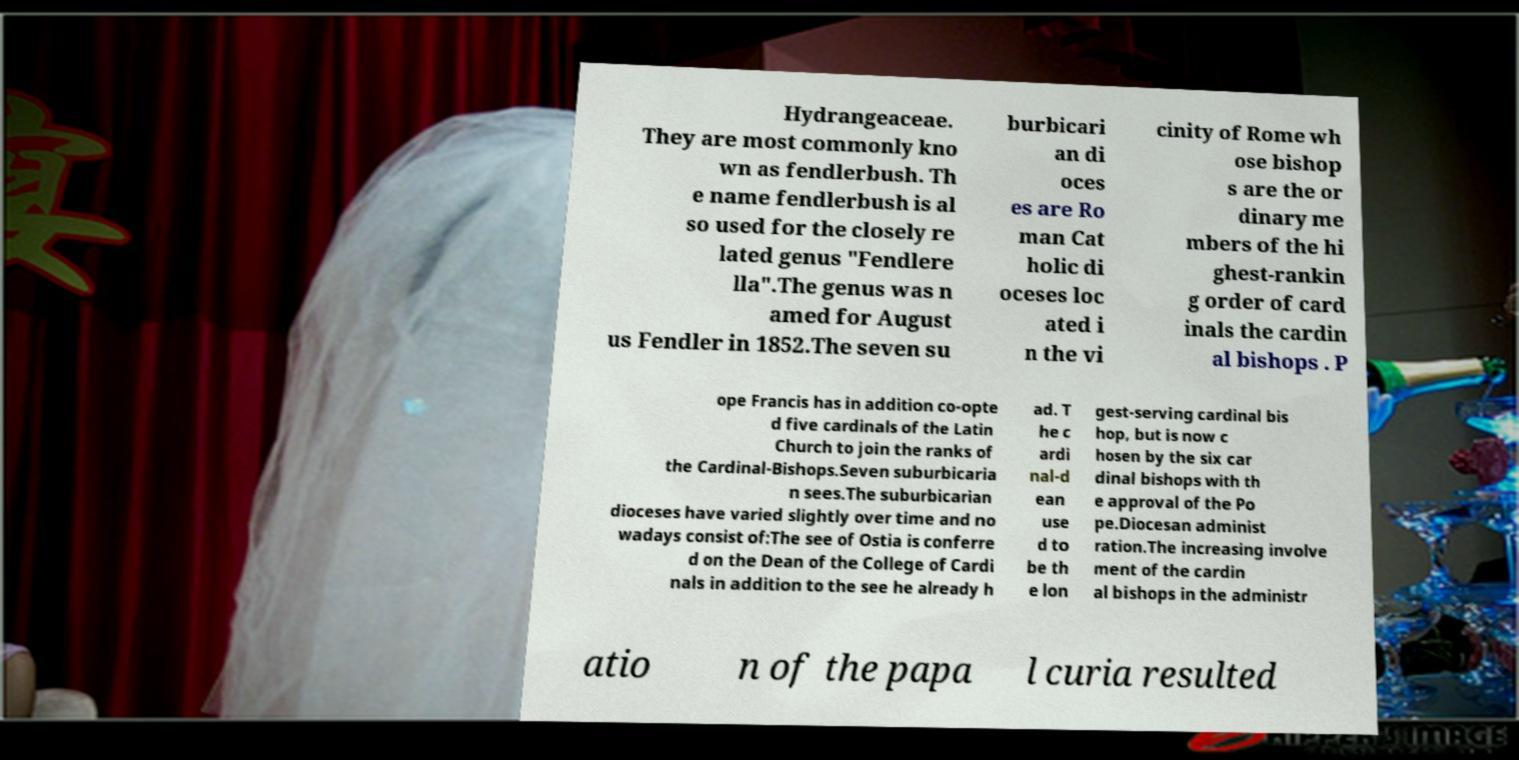Please identify and transcribe the text found in this image. Hydrangeaceae. They are most commonly kno wn as fendlerbush. Th e name fendlerbush is al so used for the closely re lated genus "Fendlere lla".The genus was n amed for August us Fendler in 1852.The seven su burbicari an di oces es are Ro man Cat holic di oceses loc ated i n the vi cinity of Rome wh ose bishop s are the or dinary me mbers of the hi ghest-rankin g order of card inals the cardin al bishops . P ope Francis has in addition co-opte d five cardinals of the Latin Church to join the ranks of the Cardinal-Bishops.Seven suburbicaria n sees.The suburbicarian dioceses have varied slightly over time and no wadays consist of:The see of Ostia is conferre d on the Dean of the College of Cardi nals in addition to the see he already h ad. T he c ardi nal-d ean use d to be th e lon gest-serving cardinal bis hop, but is now c hosen by the six car dinal bishops with th e approval of the Po pe.Diocesan administ ration.The increasing involve ment of the cardin al bishops in the administr atio n of the papa l curia resulted 